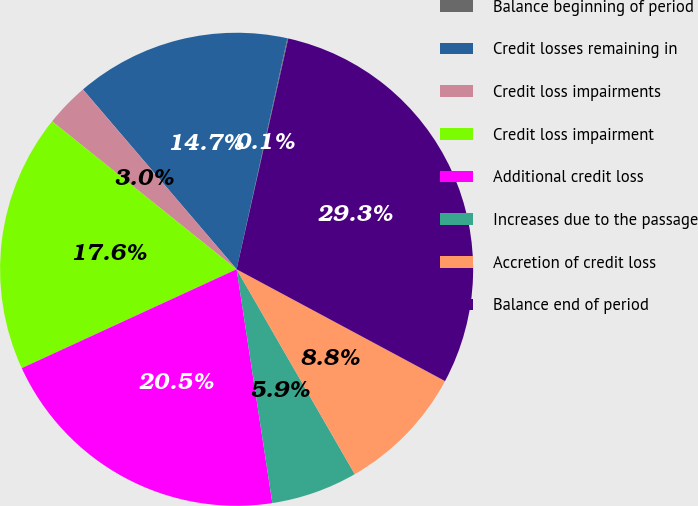Convert chart to OTSL. <chart><loc_0><loc_0><loc_500><loc_500><pie_chart><fcel>Balance beginning of period<fcel>Credit losses remaining in<fcel>Credit loss impairments<fcel>Credit loss impairment<fcel>Additional credit loss<fcel>Increases due to the passage<fcel>Accretion of credit loss<fcel>Balance end of period<nl><fcel>0.06%<fcel>14.7%<fcel>2.99%<fcel>17.62%<fcel>20.55%<fcel>5.91%<fcel>8.84%<fcel>29.33%<nl></chart> 